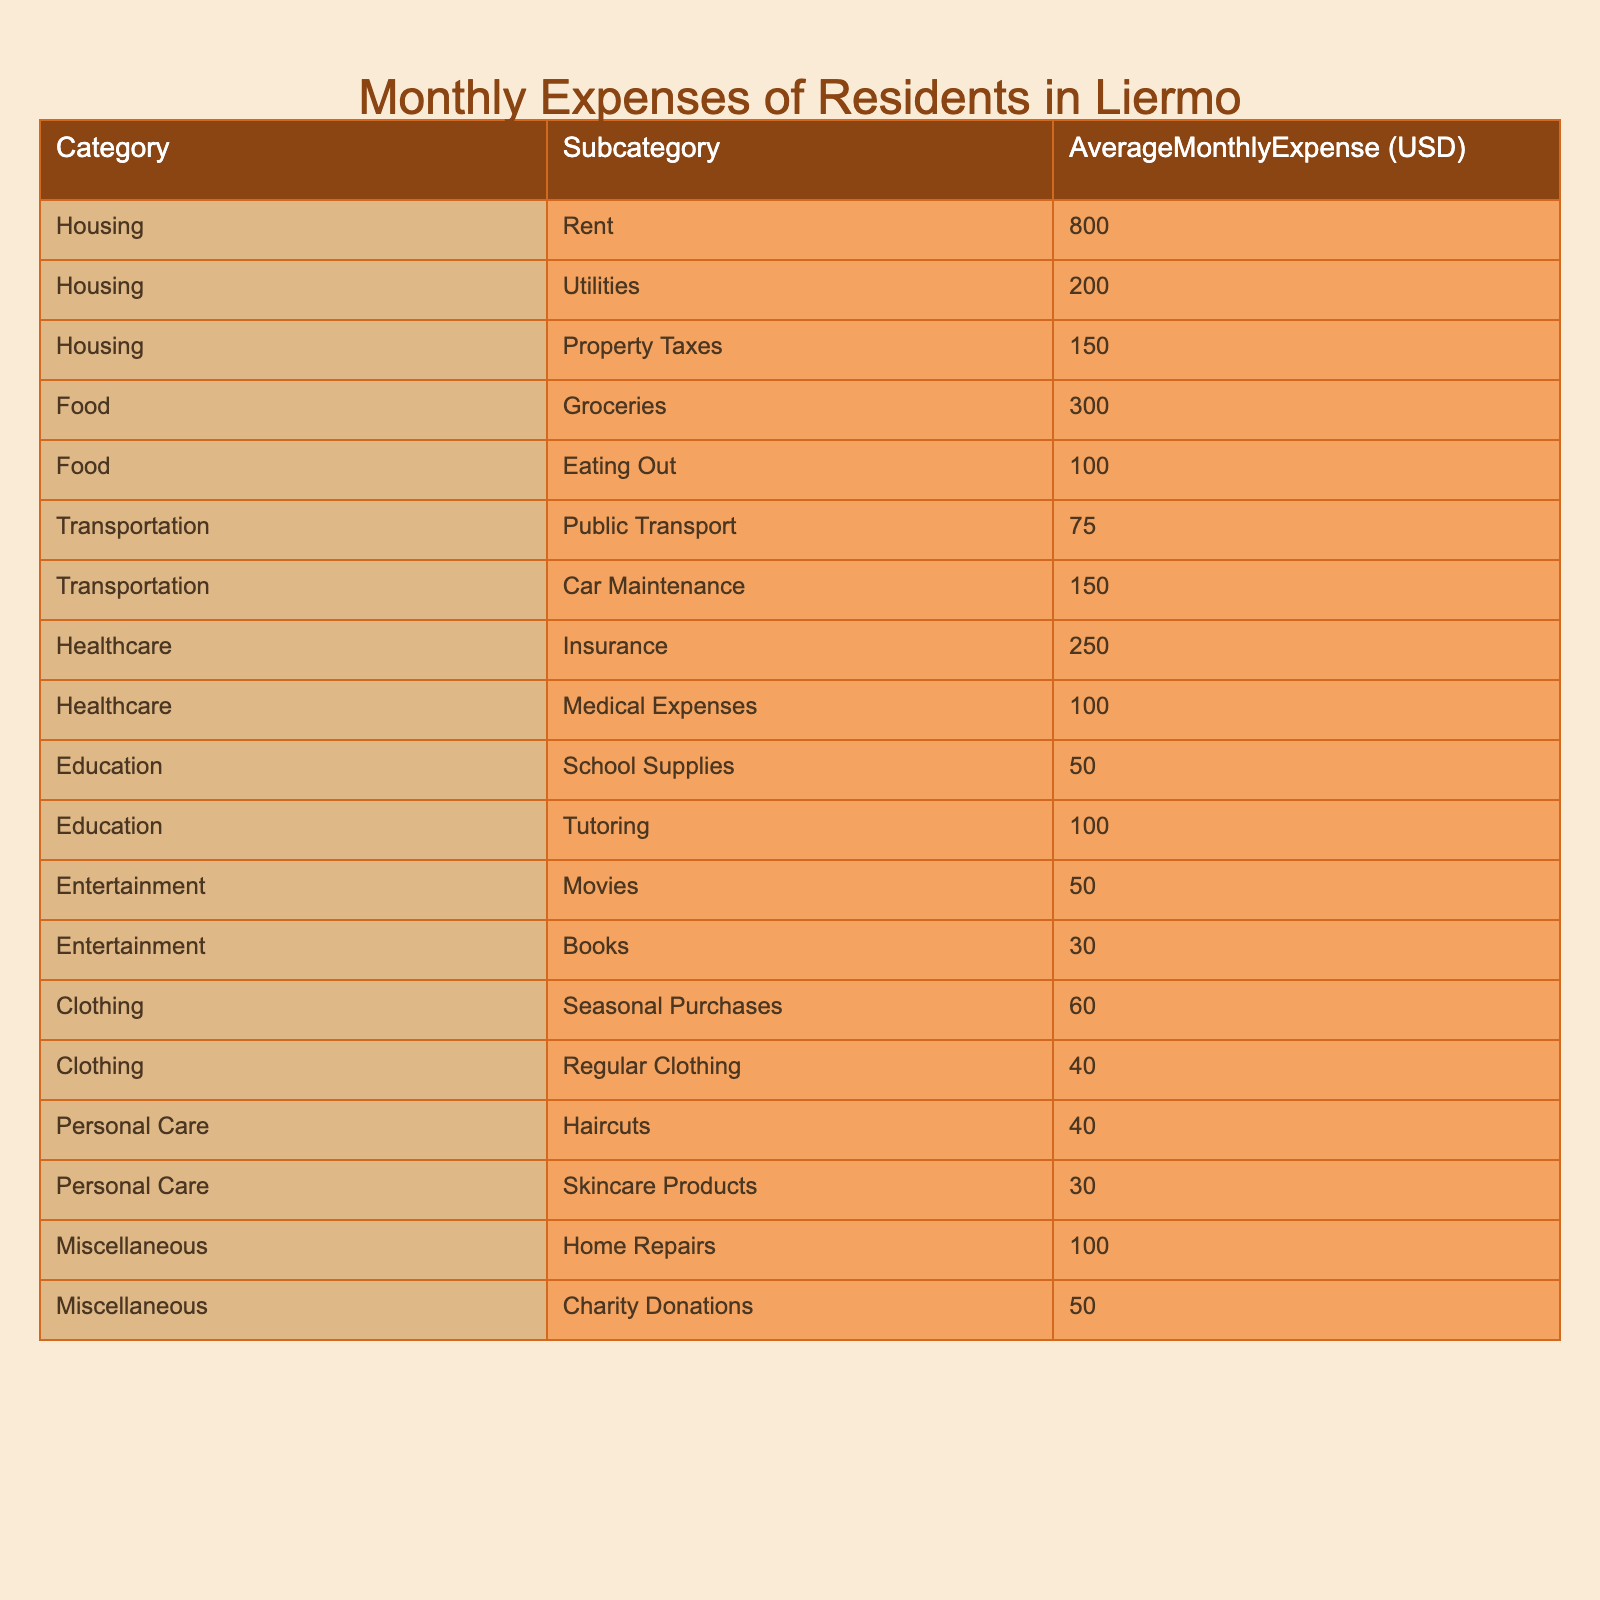What is the average monthly expense for housing in Liermo? To find the average monthly expense for housing, we sum the expenses in the Housing category: Rent ($800), Utilities ($200), and Property Taxes ($150). The total is $800 + $200 + $150 = $1150.
Answer: 1150 Which subcategory of food has the highest average monthly expense? In the Food category, we compare Groceries ($300) and Eating Out ($100). Groceries is the highest expense, so it has the highest average.
Answer: Groceries What is the total average monthly expense for personal care? For Personal Care, we add Haircuts ($40) and Skincare Products ($30). The total is $40 + $30 = $70.
Answer: 70 Is the average monthly expense for public transport greater than for car maintenance? The average monthly expense for Public Transport is $75 and for Car Maintenance is $150. Since $75 is not greater than $150, the answer is false.
Answer: No What is the difference between the average monthly expenses for healthcare and transportation? The average monthly expense for Healthcare is $250, and for Transportation, it is $75. We calculate the difference: $250 - $75 = $175.
Answer: 175 What would the total monthly expenses be if we include charity donations from miscellaneous expenses? We will sum all categories, and include charity donations. The total expenses are: $1150 (Housing) + $400 (Food) + $225 (Transportation) + $350 (Healthcare) + $150 (Education) + $80 (Entertainment) + $100 (Clothing) + $70 (Personal Care) + $100 (Miscellaneous) = $2675. Adding in charity donations ($50), the total is $2675 + $50 = $2725.
Answer: 2725 Which categories have an average monthly expense less than 100 USD? We look at all the categories: Eating Out, Public Transport, School Supplies, and Entertainment (Movies and Books) all have averages below $100. Therefore, there are multiple categories.
Answer: Multiple Which category accounts for the least amount of average monthly expense? The category with the least total average monthly expense is Clothing, with the lowest subcategory being Regular Clothing ($40) compared to others in the chart.
Answer: Clothing What is the total average monthly expense for the education category? The educational expenses consist of School Supplies ($50) and Tutoring ($100). Summing these gives $50 + $100 = $150 as the total.
Answer: 150 If a resident spends exactly the average on each category, how much do they spend on entertainment in total? In Entertainment, there are two subcategories: Movies ($50) and Books ($30). We find the total by adding these: $50 + $30 = $80 for their total entertainment expenses.
Answer: 80 